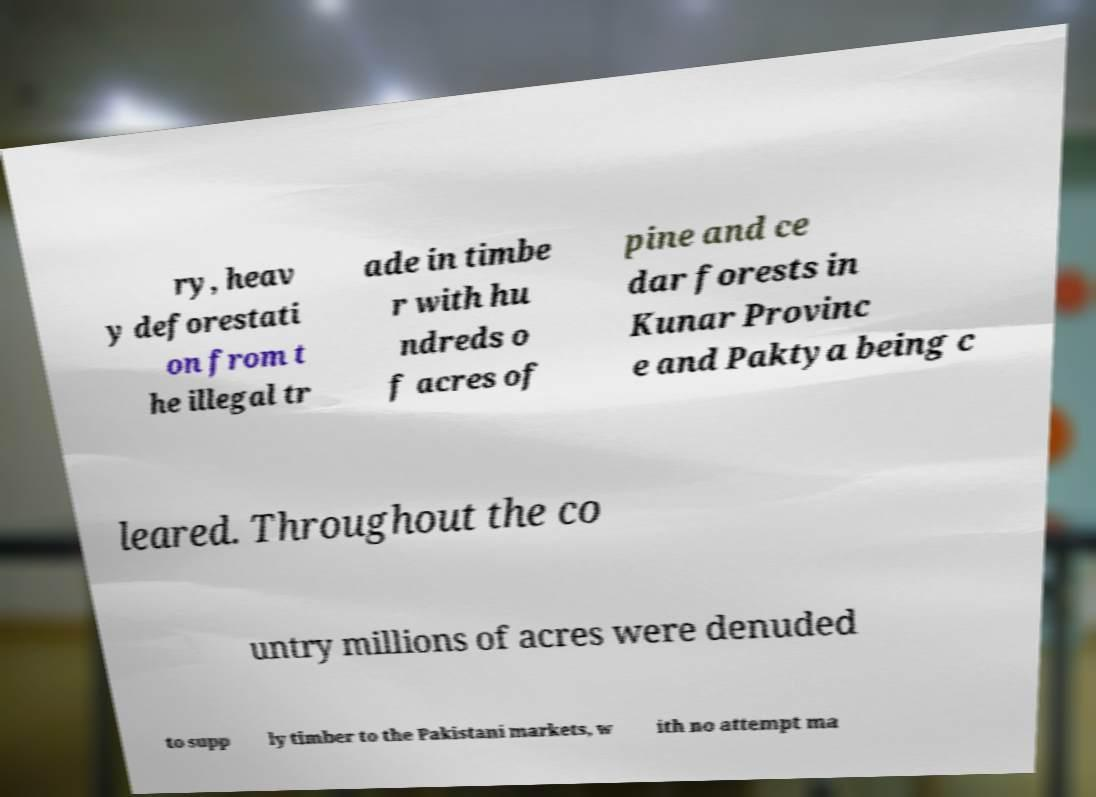Could you extract and type out the text from this image? ry, heav y deforestati on from t he illegal tr ade in timbe r with hu ndreds o f acres of pine and ce dar forests in Kunar Provinc e and Paktya being c leared. Throughout the co untry millions of acres were denuded to supp ly timber to the Pakistani markets, w ith no attempt ma 